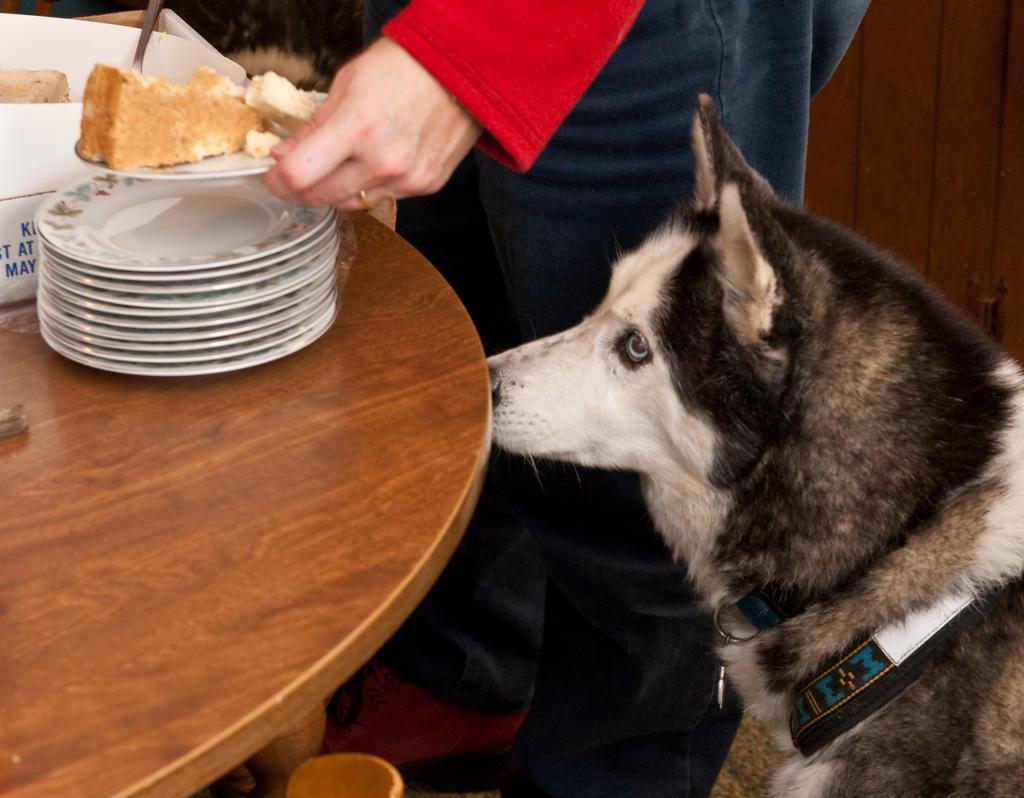In one or two sentences, can you explain what this image depicts? There is food and plates on a table. On the left there is a dog and a person holding food in the plate. 